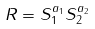Convert formula to latex. <formula><loc_0><loc_0><loc_500><loc_500>R = S ^ { a _ { 1 } } _ { 1 } S ^ { a _ { 2 } } _ { 2 }</formula> 